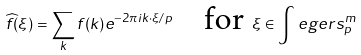<formula> <loc_0><loc_0><loc_500><loc_500>\widehat { f } ( \xi ) = \sum _ { k } f ( k ) e ^ { - 2 \pi i k \cdot \xi / p } \quad \text {for } \xi \in \int e g e r s _ { p } ^ { m }</formula> 